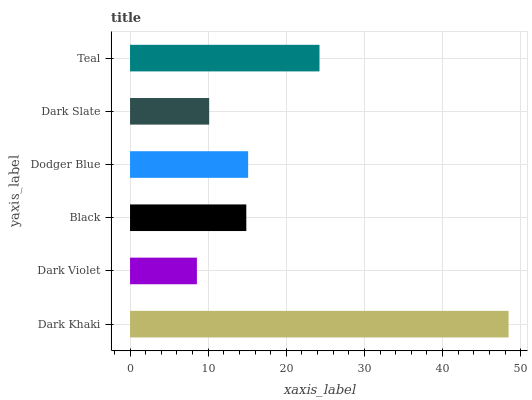Is Dark Violet the minimum?
Answer yes or no. Yes. Is Dark Khaki the maximum?
Answer yes or no. Yes. Is Black the minimum?
Answer yes or no. No. Is Black the maximum?
Answer yes or no. No. Is Black greater than Dark Violet?
Answer yes or no. Yes. Is Dark Violet less than Black?
Answer yes or no. Yes. Is Dark Violet greater than Black?
Answer yes or no. No. Is Black less than Dark Violet?
Answer yes or no. No. Is Dodger Blue the high median?
Answer yes or no. Yes. Is Black the low median?
Answer yes or no. Yes. Is Teal the high median?
Answer yes or no. No. Is Dark Violet the low median?
Answer yes or no. No. 